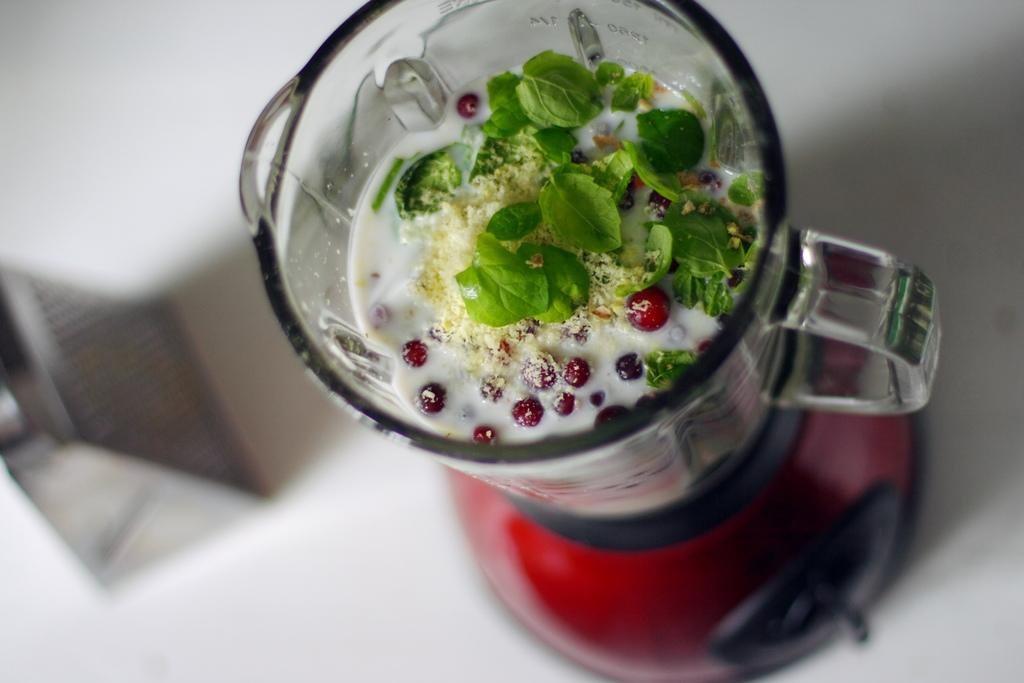What is inside the jar that is visible in the image? There is a food item in the jar that is visible in the image. Where is the jar located in the image? The jar is on a grinder in the image. What else can be seen on the white surface in the image? There is an object on the white surface in the image. What type of meal is being prepared on the white surface in the image? There is no meal preparation visible in the image; it only shows a jar with a food item on a grinder and an object on a white surface. 